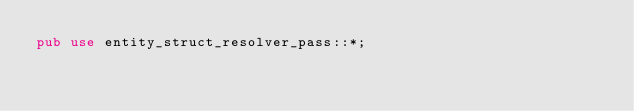Convert code to text. <code><loc_0><loc_0><loc_500><loc_500><_Rust_>pub use entity_struct_resolver_pass::*;
</code> 